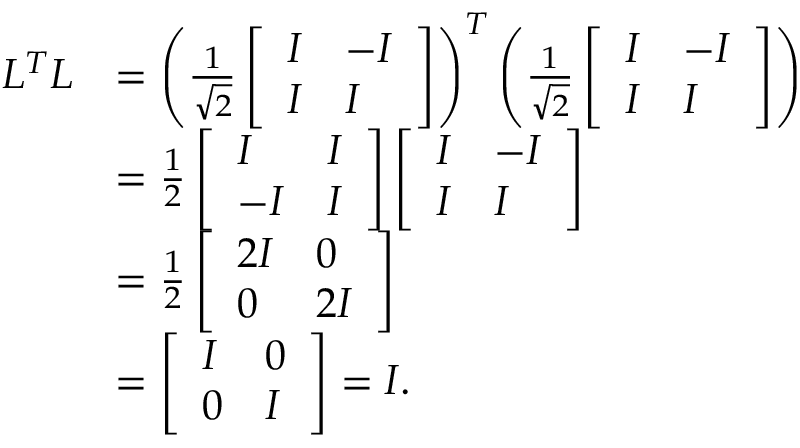Convert formula to latex. <formula><loc_0><loc_0><loc_500><loc_500>\begin{array} { r l } { L ^ { T } L } & { = \left ( \frac { 1 } { \sqrt { 2 } } \left [ \begin{array} { l l } { I } & { - I } \\ { I } & { I } \end{array} \right ] \right ) ^ { T } \left ( \frac { 1 } { \sqrt { 2 } } \left [ \begin{array} { l l } { I } & { - I } \\ { I } & { I } \end{array} \right ] \right ) } \\ & { = \frac { 1 } { 2 } \left [ \begin{array} { l l } { I } & { I } \\ { - I } & { I } \end{array} \right ] \left [ \begin{array} { l l } { I } & { - I } \\ { I } & { I } \end{array} \right ] } \\ & { = \frac { 1 } { 2 } \left [ \begin{array} { l l } { 2 I } & { 0 } \\ { 0 } & { 2 I } \end{array} \right ] } \\ & { = \left [ \begin{array} { l l } { I } & { 0 } \\ { 0 } & { I } \end{array} \right ] = I . } \end{array}</formula> 